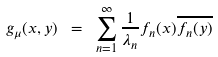<formula> <loc_0><loc_0><loc_500><loc_500>g _ { \mu } ( x , y ) \ = \ \sum _ { n = 1 } ^ { \infty } \frac { 1 } { \lambda _ { n } } f _ { n } ( x ) \overline { f _ { n } ( y ) }</formula> 